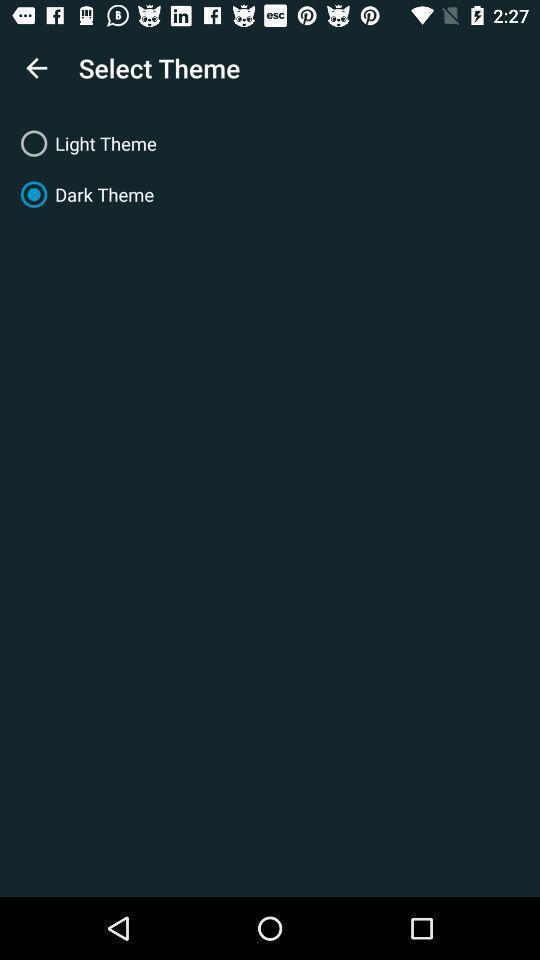Summarize the information in this screenshot. Theme settings in the application. 